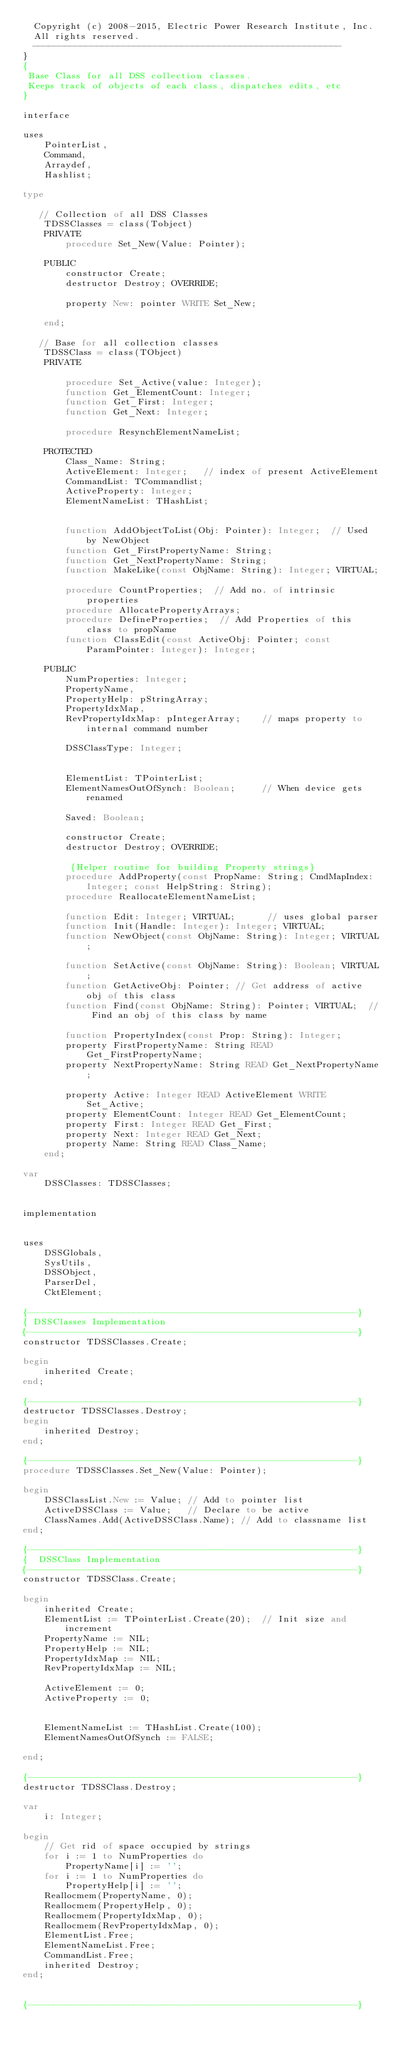<code> <loc_0><loc_0><loc_500><loc_500><_Pascal_>  Copyright (c) 2008-2015, Electric Power Research Institute, Inc.
  All rights reserved.
  ----------------------------------------------------------
}
{
 Base Class for all DSS collection classes.
 Keeps track of objects of each class, dispatches edits, etc
}

interface

uses
    PointerList,
    Command,
    Arraydef,
    Hashlist;

type

   // Collection of all DSS Classes
    TDSSClasses = class(Tobject)
    PRIVATE
        procedure Set_New(Value: Pointer);

    PUBLIC
        constructor Create;
        destructor Destroy; OVERRIDE;

        property New: pointer WRITE Set_New;

    end;

   // Base for all collection classes
    TDSSClass = class(TObject)
    PRIVATE

        procedure Set_Active(value: Integer);
        function Get_ElementCount: Integer;
        function Get_First: Integer;
        function Get_Next: Integer;

        procedure ResynchElementNameList;

    PROTECTED
        Class_Name: String;
        ActiveElement: Integer;   // index of present ActiveElement
        CommandList: TCommandlist;
        ActiveProperty: Integer;
        ElementNameList: THashList;


        function AddObjectToList(Obj: Pointer): Integer;  // Used by NewObject
        function Get_FirstPropertyName: String;
        function Get_NextPropertyName: String;
        function MakeLike(const ObjName: String): Integer; VIRTUAL;

        procedure CountProperties;  // Add no. of intrinsic properties
        procedure AllocatePropertyArrays;
        procedure DefineProperties;  // Add Properties of this class to propName
        function ClassEdit(const ActiveObj: Pointer; const ParamPointer: Integer): Integer;

    PUBLIC
        NumProperties: Integer;
        PropertyName,
        PropertyHelp: pStringArray;
        PropertyIdxMap,
        RevPropertyIdxMap: pIntegerArray;    // maps property to internal command number

        DSSClassType: Integer;


        ElementList: TPointerList;
        ElementNamesOutOfSynch: Boolean;     // When device gets renamed

        Saved: Boolean;

        constructor Create;
        destructor Destroy; OVERRIDE;

         {Helper routine for building Property strings}
        procedure AddProperty(const PropName: String; CmdMapIndex: Integer; const HelpString: String);
        procedure ReallocateElementNameList;

        function Edit: Integer; VIRTUAL;      // uses global parser
        function Init(Handle: Integer): Integer; VIRTUAL;
        function NewObject(const ObjName: String): Integer; VIRTUAL;

        function SetActive(const ObjName: String): Boolean; VIRTUAL;
        function GetActiveObj: Pointer; // Get address of active obj of this class
        function Find(const ObjName: String): Pointer; VIRTUAL;  // Find an obj of this class by name

        function PropertyIndex(const Prop: String): Integer;
        property FirstPropertyName: String READ Get_FirstPropertyName;
        property NextPropertyName: String READ Get_NextPropertyName;

        property Active: Integer READ ActiveElement WRITE Set_Active;
        property ElementCount: Integer READ Get_ElementCount;
        property First: Integer READ Get_First;
        property Next: Integer READ Get_Next;
        property Name: String READ Class_Name;
    end;

var
    DSSClasses: TDSSClasses;


implementation


uses
    DSSGlobals,
    SysUtils,
    DSSObject,
    ParserDel,
    CktElement;

{--------------------------------------------------------------}
{ DSSClasses Implementation
{--------------------------------------------------------------}
constructor TDSSClasses.Create;

begin
    inherited Create;
end;

{--------------------------------------------------------------}
destructor TDSSClasses.Destroy;
begin
    inherited Destroy;
end;

{--------------------------------------------------------------}
procedure TDSSClasses.Set_New(Value: Pointer);

begin
    DSSClassList.New := Value; // Add to pointer list
    ActiveDSSClass := Value;   // Declare to be active
    ClassNames.Add(ActiveDSSClass.Name); // Add to classname list
end;

{--------------------------------------------------------------}
{  DSSClass Implementation
{--------------------------------------------------------------}
constructor TDSSClass.Create;

begin
    inherited Create;
    ElementList := TPointerList.Create(20);  // Init size and increment
    PropertyName := NIL;
    PropertyHelp := NIL;
    PropertyIdxMap := NIL;
    RevPropertyIdxMap := NIL;

    ActiveElement := 0;
    ActiveProperty := 0;


    ElementNameList := THashList.Create(100);
    ElementNamesOutOfSynch := FALSE;

end;

{--------------------------------------------------------------}
destructor TDSSClass.Destroy;

var
    i: Integer;

begin
    // Get rid of space occupied by strings
    for i := 1 to NumProperties do
        PropertyName[i] := '';
    for i := 1 to NumProperties do
        PropertyHelp[i] := '';
    Reallocmem(PropertyName, 0);
    Reallocmem(PropertyHelp, 0);
    Reallocmem(PropertyIdxMap, 0);
    Reallocmem(RevPropertyIdxMap, 0);
    ElementList.Free;
    ElementNameList.Free;
    CommandList.Free;
    inherited Destroy;
end;


{--------------------------------------------------------------}</code> 